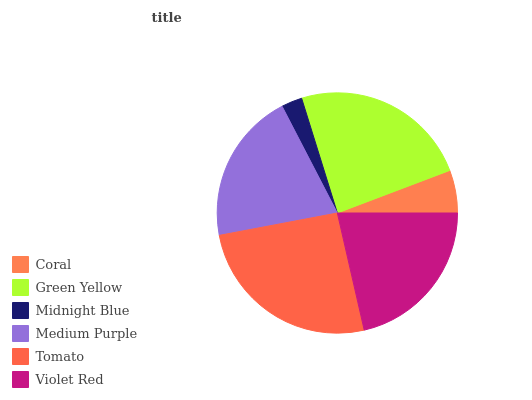Is Midnight Blue the minimum?
Answer yes or no. Yes. Is Tomato the maximum?
Answer yes or no. Yes. Is Green Yellow the minimum?
Answer yes or no. No. Is Green Yellow the maximum?
Answer yes or no. No. Is Green Yellow greater than Coral?
Answer yes or no. Yes. Is Coral less than Green Yellow?
Answer yes or no. Yes. Is Coral greater than Green Yellow?
Answer yes or no. No. Is Green Yellow less than Coral?
Answer yes or no. No. Is Violet Red the high median?
Answer yes or no. Yes. Is Medium Purple the low median?
Answer yes or no. Yes. Is Medium Purple the high median?
Answer yes or no. No. Is Midnight Blue the low median?
Answer yes or no. No. 